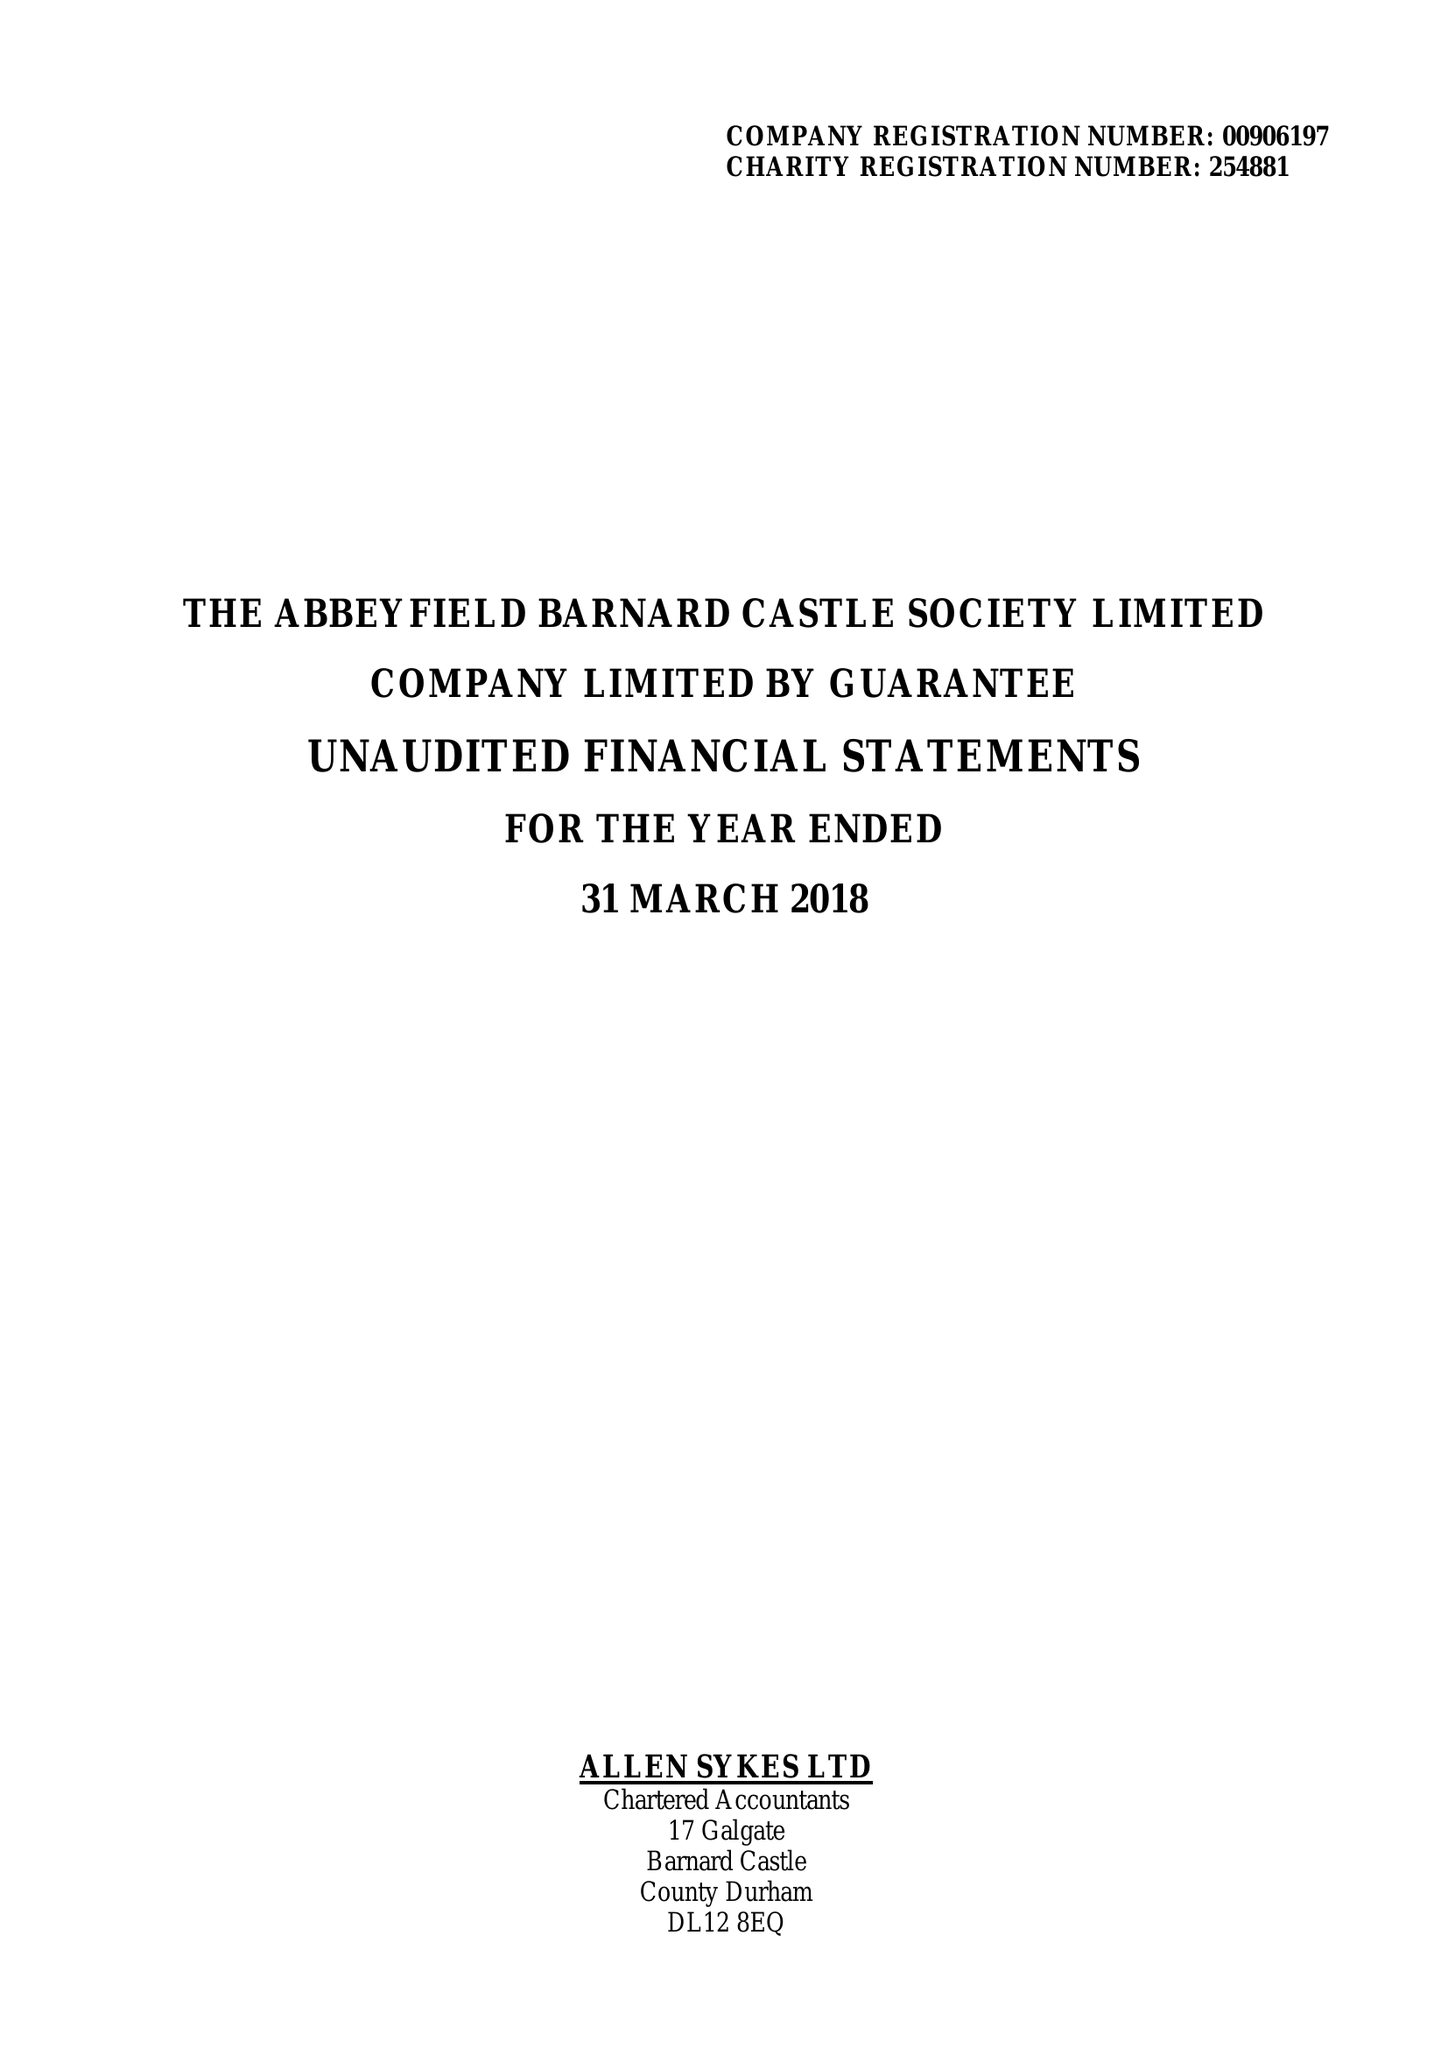What is the value for the address__street_line?
Answer the question using a single word or phrase. None 